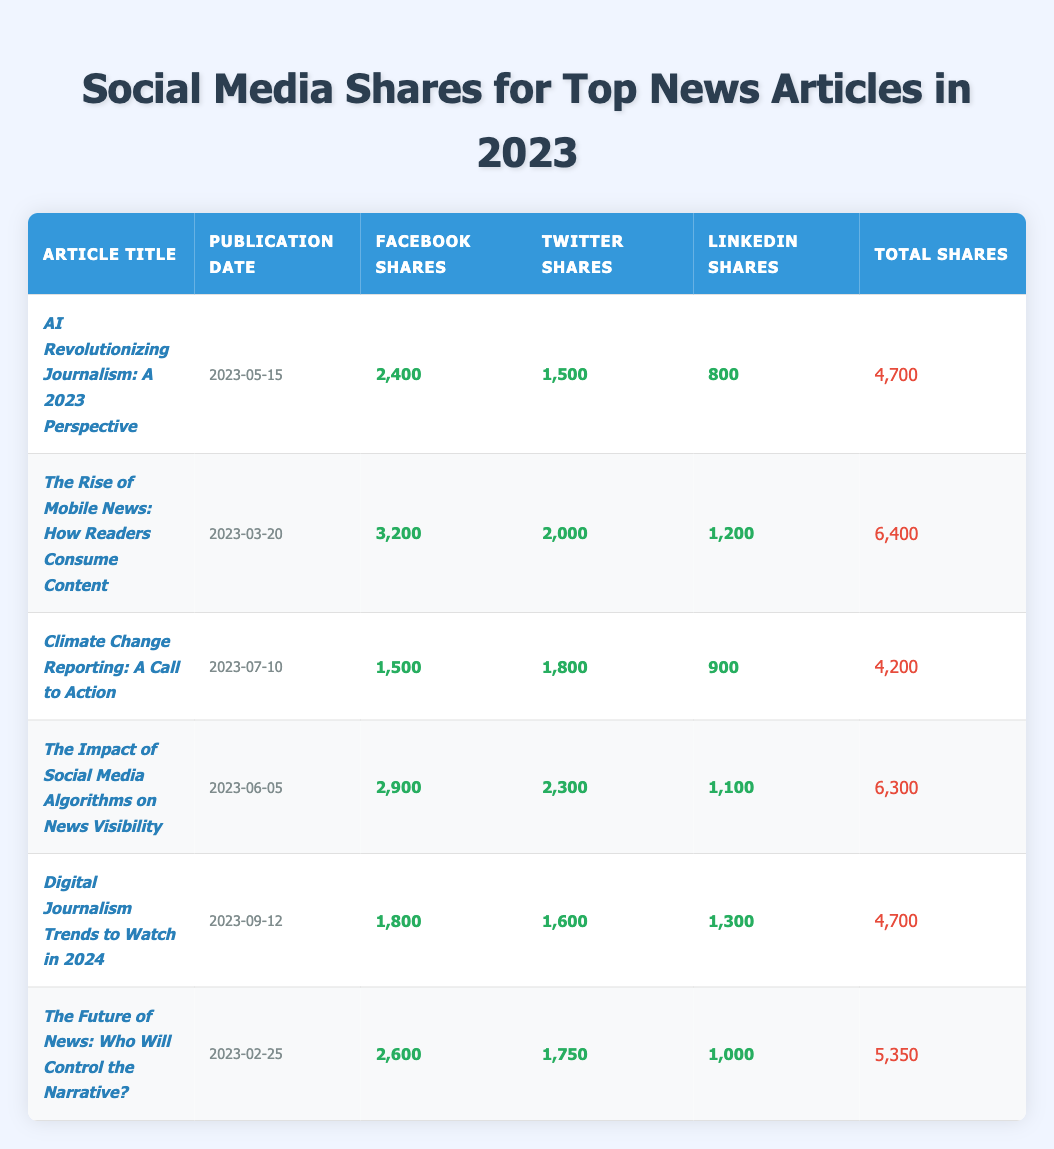What is the total number of shares for the article titled *The Rise of Mobile News: How Readers Consume Content*? The total shares can be found in the table under the column labeled "Total Shares." For this article, the value is listed as 6,400.
Answer: 6,400 Which article received the highest number of Facebook shares? By examining the Facebook shares column, *The Rise of Mobile News: How Readers Consume Content* has the highest value at 3,200 shares.
Answer: *The Rise of Mobile News: How Readers Consume Content* What is the average number of Twitter shares across all articles? To find the average, we sum all Twitter shares: 1,500 + 2,000 + 1,800 + 2,300 + 1,600 + 1,750 = 10,150; there are 6 articles, so the average is 10,150 / 6 = 1,691.67.
Answer: 1,691.67 Did *Digital Journalism Trends to Watch in 2024* have more LinkedIn shares than *Climate Change Reporting: A Call to Action*? Checking the LinkedIn shares, *Digital Journalism Trends to Watch in 2024* has 1,300 shares while *Climate Change Reporting: A Call to Action* has 900 shares. Thus, it is true that the former has more shares than the latter.
Answer: Yes How much more total shares did *The Impact of Social Media Algorithms on News Visibility* receive compared to *AI Revolutionizing Journalism: A 2023 Perspective*? *The Impact of Social Media Algorithms on News Visibility* has 6,300 total shares and *AI Revolutionizing Journalism: A 2023 Perspective* has 4,700 total shares. The difference is 6,300 - 4,700 = 1,600 shares.
Answer: 1,600 Which article had the least number of total shares and how many were they? The total shares can be inspected in the table. The article with the least shares is *Climate Change Reporting: A Call to Action* with a total of 4,200 shares.
Answer: 4,200 If we compare the Facebook shares of *The Future of News: Who Will Control the Narrative?* and *AI Revolutionizing Journalism: A 2023 Perspective*, which one had a higher count? *The Future of News: Who Will Control the Narrative?* had 2,600 Facebook shares and *AI Revolutionizing Journalism: A 2023 Perspective* had 2,400 shares, so the former had more.
Answer: *The Future of News: Who Will Control the Narrative?* What is the total number of LinkedIn shares across all the articles? Summing the LinkedIn shares: 800 + 1,200 + 900 + 1,100 + 1,300 + 1,000 = 6,300.
Answer: 6,300 How many articles had a total share count above 5,000? Looking at the total shares: the articles with above 5,000 shares are *The Rise of Mobile News: How Readers Consume Content* (6,400), *The Impact of Social Media Algorithms on News Visibility* (6,300), and *The Future of News: Who Will Control the Narrative?* (5,350). That makes 3 articles.
Answer: 3 